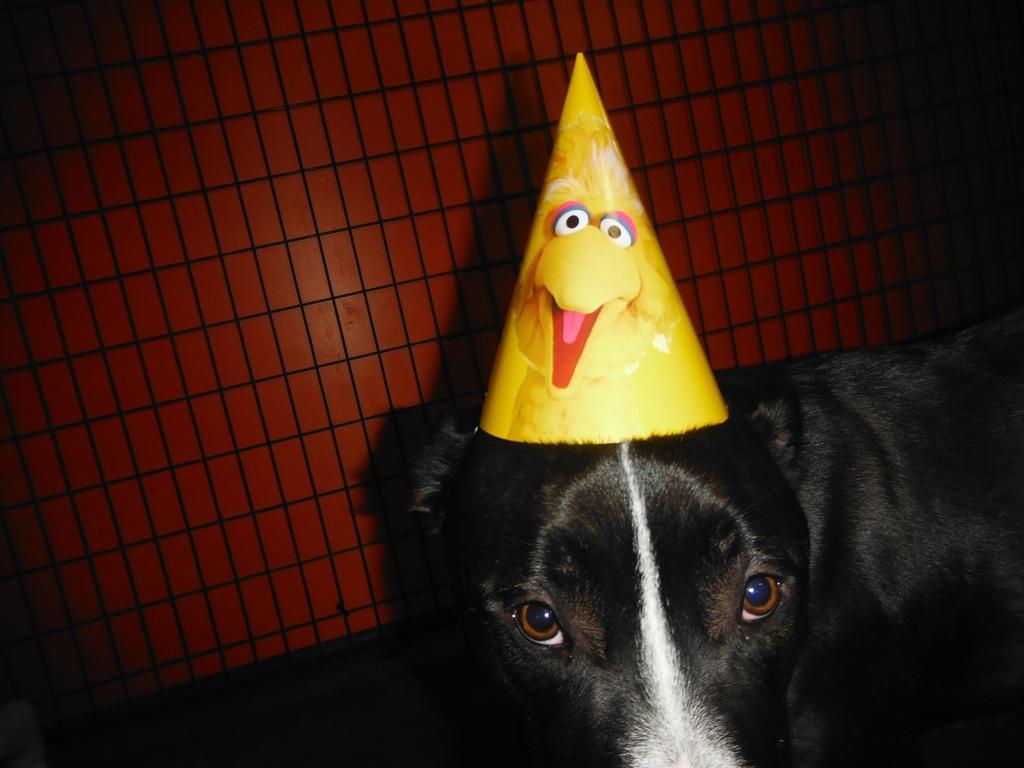What type of animal is present in the image? There is a dog in the image. What is the dog wearing? The dog is wearing a hat. Can you describe any unique features of the image? There is a mesh visible on the backside of the dog or the image. What type of help can be seen being provided by the dog in the image? There is no indication of the dog providing help in the image. 